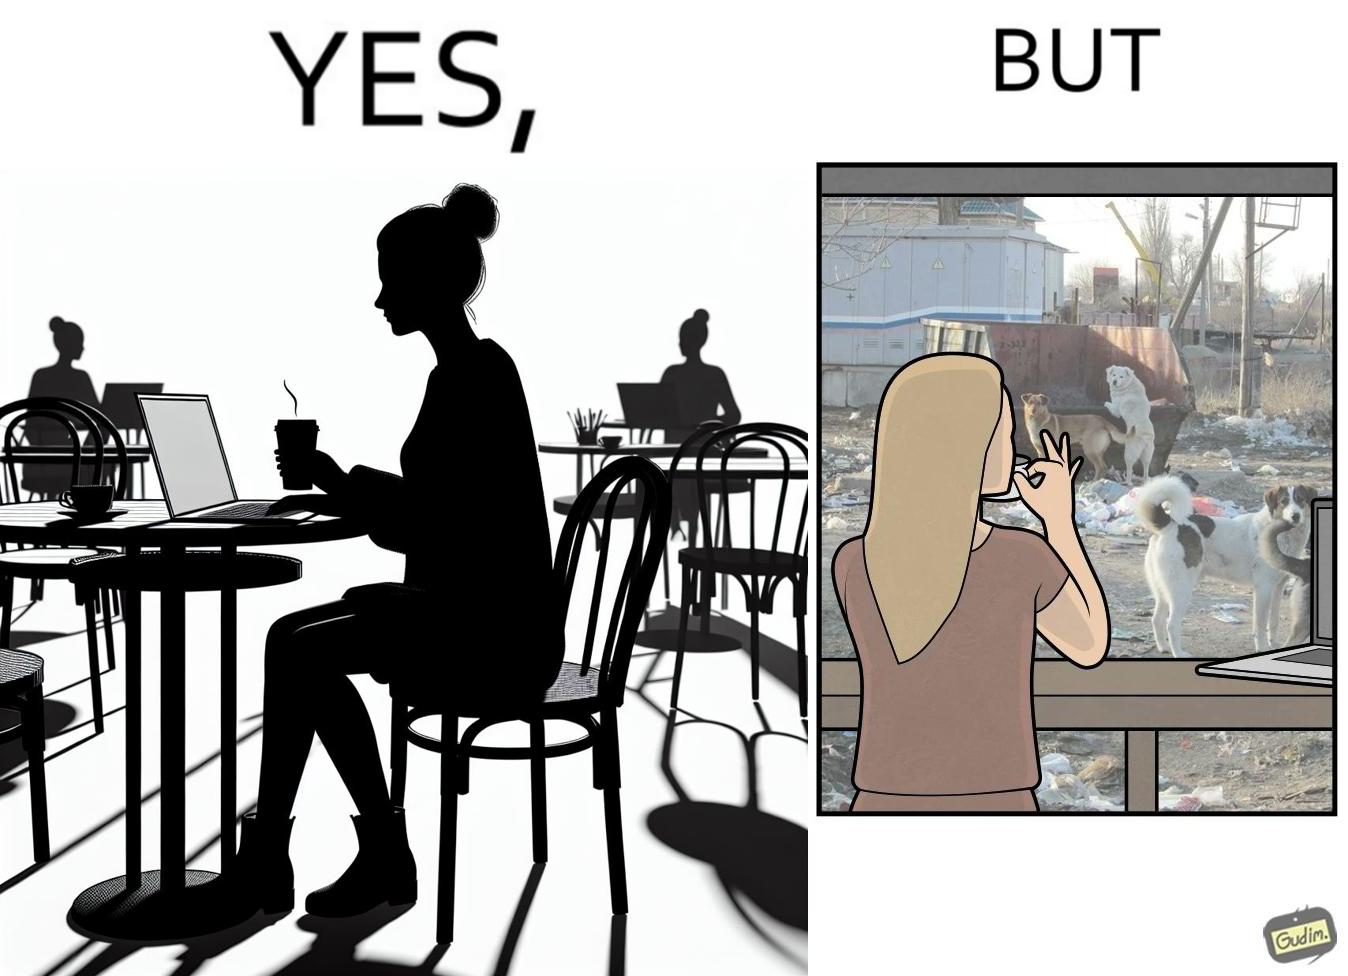Describe what you see in this image. The people nowadays are not concerned about the surroundings, everyone is busy in their life, like in the image it is shown that even when the woman notices the issues faced by stray but even then she is not ready to raise her voice or do some action for the cause 